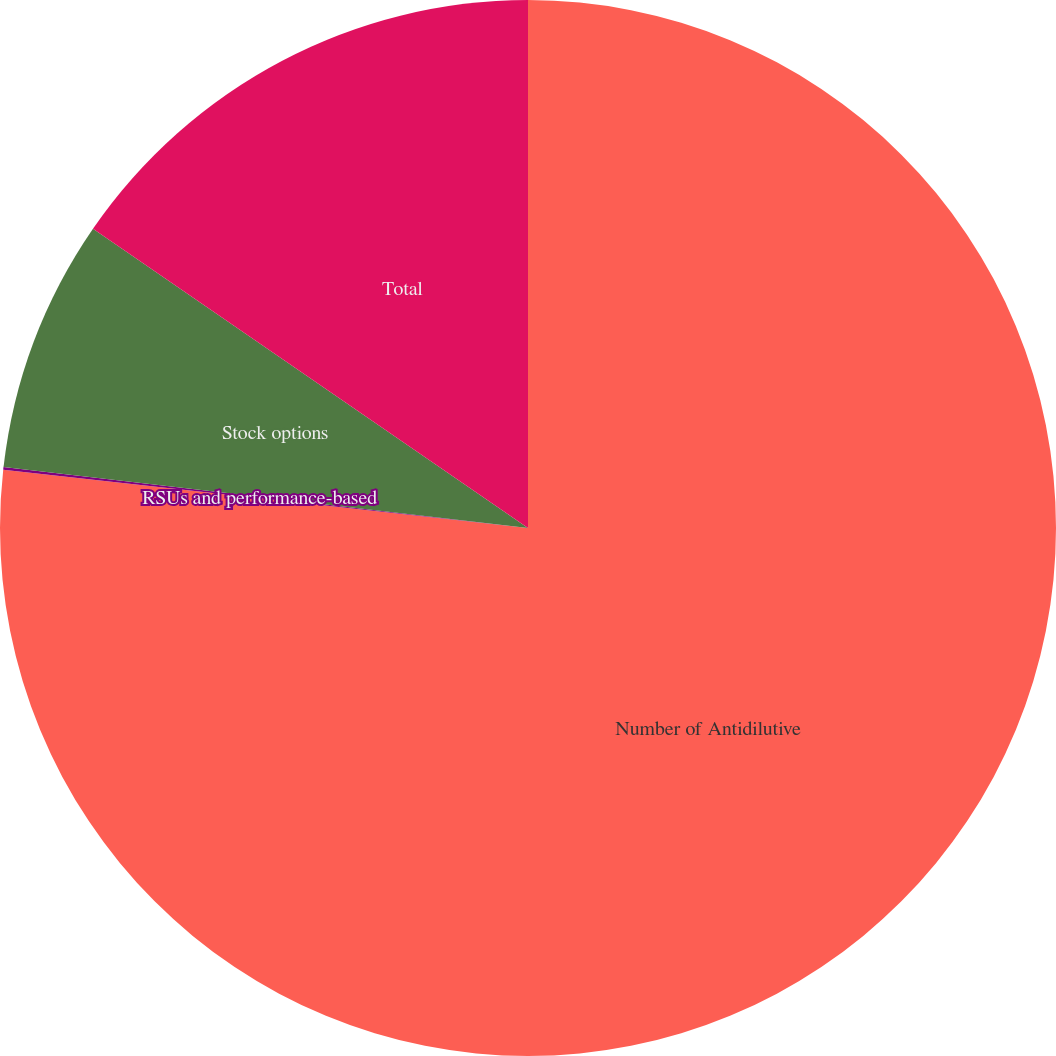<chart> <loc_0><loc_0><loc_500><loc_500><pie_chart><fcel>Number of Antidilutive<fcel>RSUs and performance-based<fcel>Stock options<fcel>Total<nl><fcel>76.76%<fcel>0.08%<fcel>7.75%<fcel>15.41%<nl></chart> 